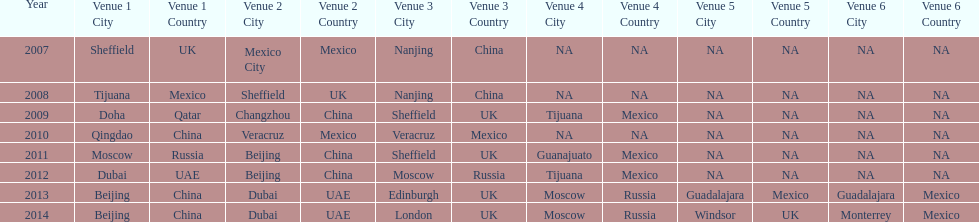In list of venues, how many years was beijing above moscow (1st venue is above 2nd venue, etc)? 3. 